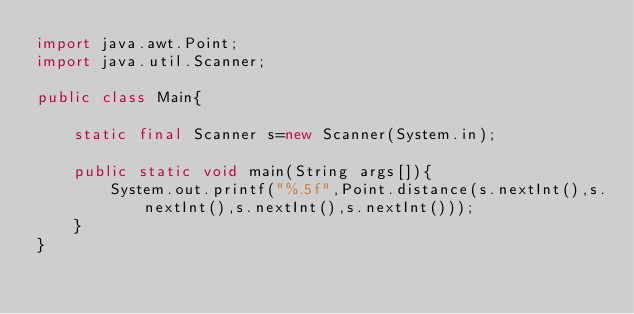Convert code to text. <code><loc_0><loc_0><loc_500><loc_500><_Java_>import java.awt.Point;
import java.util.Scanner;

public class Main{

	static final Scanner s=new Scanner(System.in);

	public static void main(String args[]){
		System.out.printf("%.5f",Point.distance(s.nextInt(),s.nextInt(),s.nextInt(),s.nextInt()));
	}
}</code> 